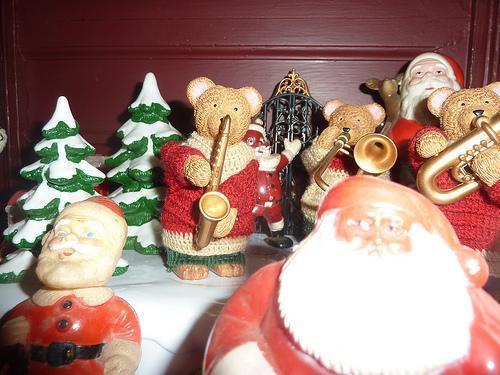How many bears are there?
Give a very brief answer. 3. 